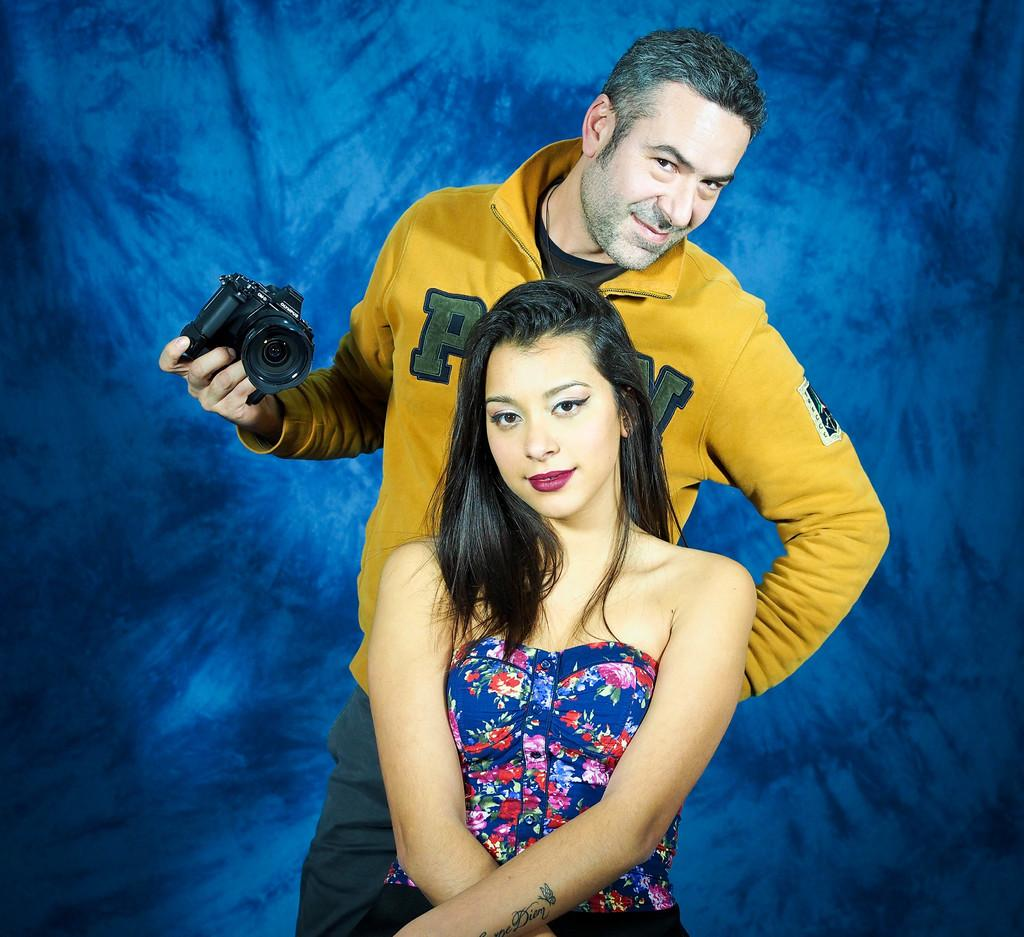What is the man in the image doing? The man is standing in the image. What is the woman in the image doing? The woman is sitting in the image. What object is the man holding in his hand? The man is holding a camera in his hand. What color is the background of the image? The background of the image has a navy green color. What type of crook can be seen in the image? There is no crook present in the image. Is there a map visible in the image? There is no map visible in the image. 